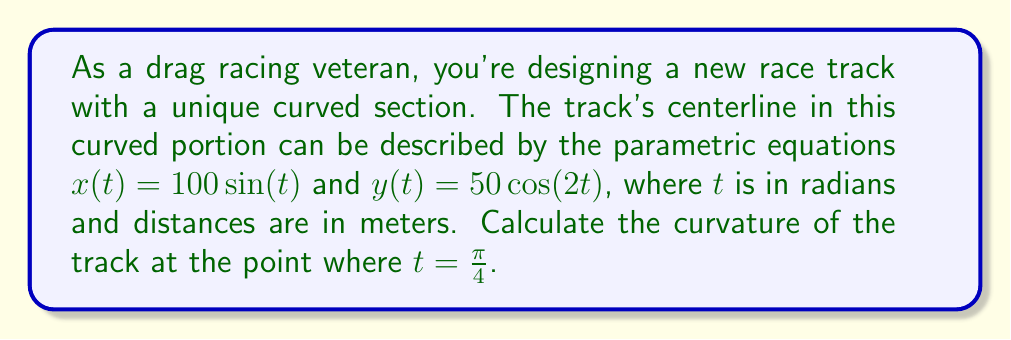Show me your answer to this math problem. To calculate the curvature of the race track using differential geometry, we'll follow these steps:

1) The curvature $\kappa$ of a parametric curve $(x(t), y(t))$ is given by:

   $$\kappa = \frac{|x'y'' - y'x''|}{(x'^2 + y'^2)^{3/2}}$$

2) Let's calculate the first and second derivatives of $x(t)$ and $y(t)$:

   $x'(t) = 100\cos(t)$
   $x''(t) = -100\sin(t)$
   $y'(t) = -100\sin(2t)$
   $y''(t) = -200\cos(2t)$

3) Now, let's substitute $t = \frac{\pi}{4}$ into these expressions:

   $x'(\frac{\pi}{4}) = 100\cos(\frac{\pi}{4}) = 100 \cdot \frac{\sqrt{2}}{2} = 50\sqrt{2}$
   $x''(\frac{\pi}{4}) = -100\sin(\frac{\pi}{4}) = -100 \cdot \frac{\sqrt{2}}{2} = -50\sqrt{2}$
   $y'(\frac{\pi}{4}) = -100\sin(\frac{\pi}{2}) = -100$
   $y''(\frac{\pi}{4}) = -200\cos(\frac{\pi}{2}) = 0$

4) Let's calculate the numerator of the curvature formula:

   $|x'y'' - y'x''| = |(50\sqrt{2} \cdot 0) - (-100 \cdot -50\sqrt{2})| = 5000\sqrt{2}$

5) Now for the denominator:

   $(x'^2 + y'^2)^{3/2} = ((50\sqrt{2})^2 + (-100)^2)^{3/2} = (5000 + 10000)^{3/2} = 15000^{3/2}$

6) Putting it all together:

   $$\kappa = \frac{5000\sqrt{2}}{15000^{3/2}} = \frac{5000\sqrt{2}}{15000 \cdot \sqrt{15000}} = \frac{\sqrt{2}}{3\sqrt{15000}}$$

This is the curvature of the track at the point where $t = \frac{\pi}{4}$.
Answer: $$\kappa = \frac{\sqrt{2}}{3\sqrt{15000}} \approx 0.00385 \text{ m}^{-1}$$ 